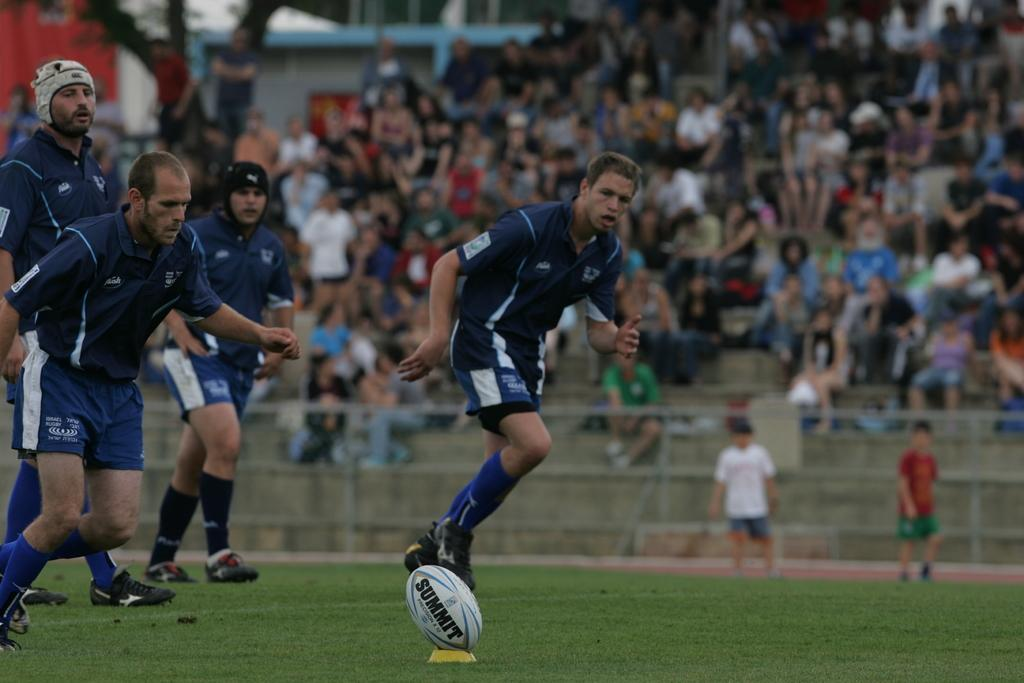How many men are in the image? There are 4 men in the image. What are the men doing in the image? The men are running and playing a sport. What color are the t-shirts the men are wearing? The men are wearing blue t-shirts. What type of clothing are the men wearing on their legs? The men are wearing shorts. What type of footwear are the men wearing? The men are wearing shoes. What can be observed about the people in the background of the image? There are many people in the background of the image, and they are observing the sport. Can you tell me how many monkeys are balancing on the men's heads in the image? There are no monkeys present in the image, and therefore none are balancing on the men's heads. 